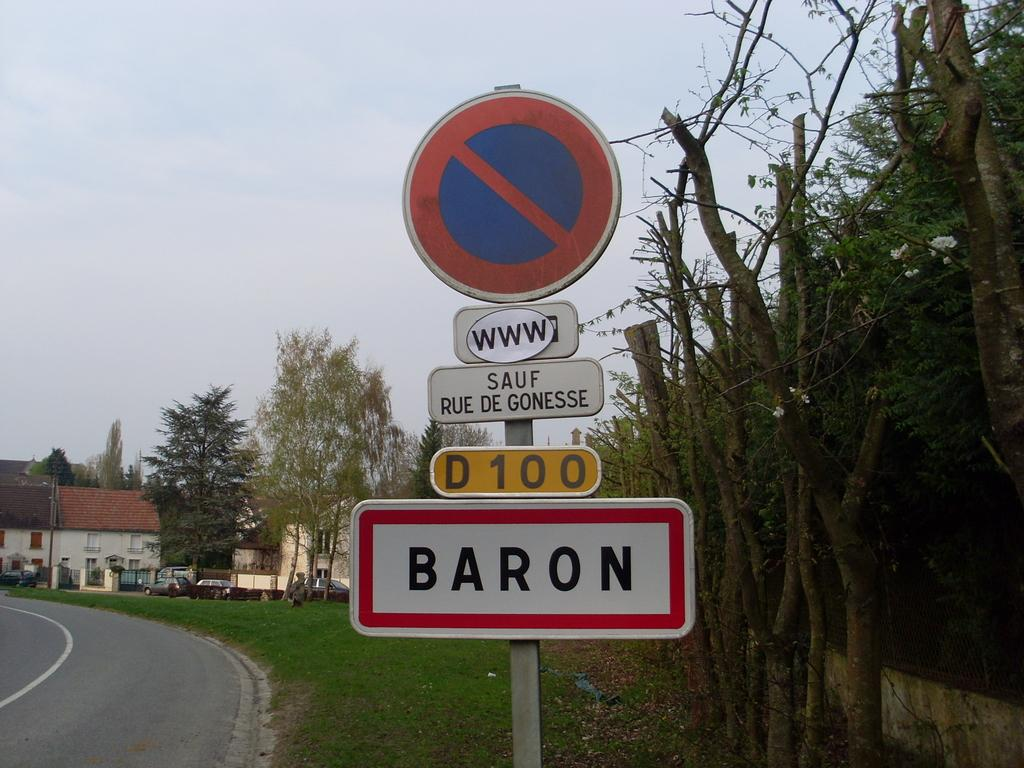Provide a one-sentence caption for the provided image. A street sign has several things written on it, including that it is Baron Street. 